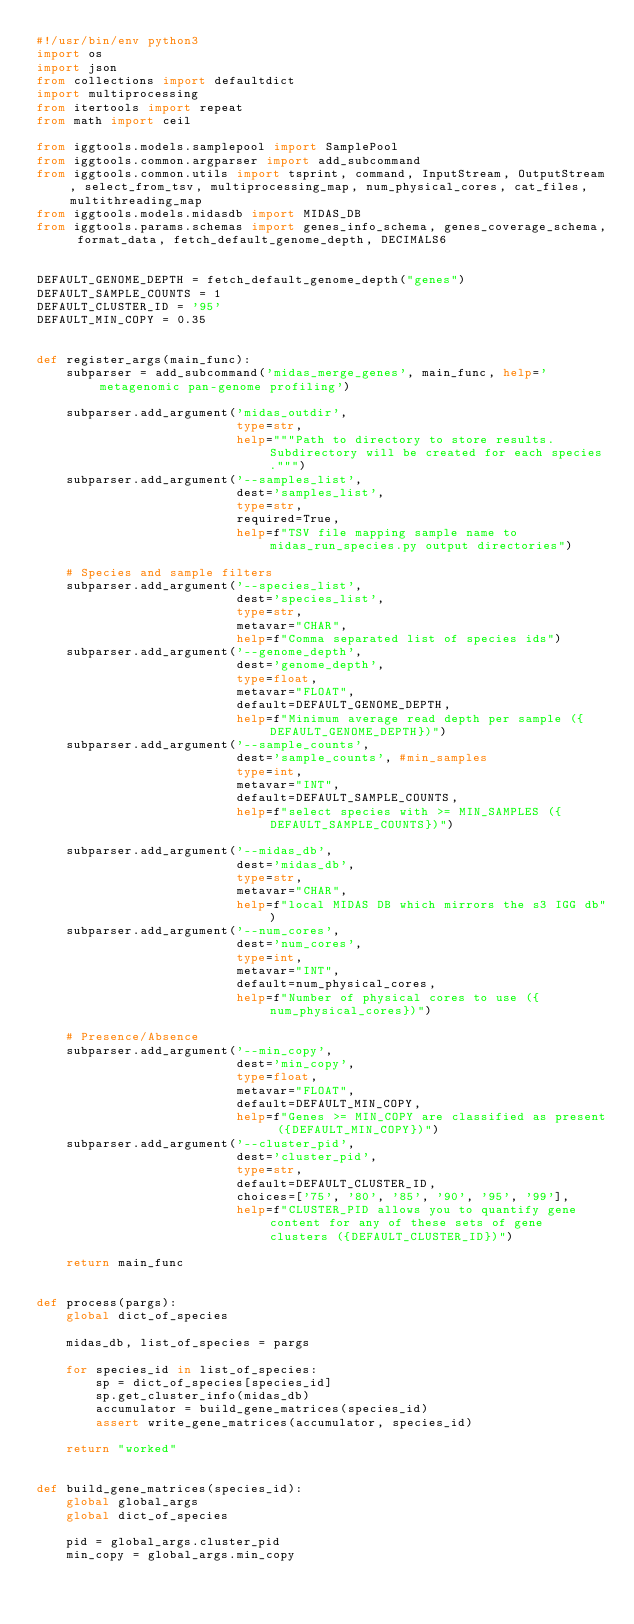Convert code to text. <code><loc_0><loc_0><loc_500><loc_500><_Python_>#!/usr/bin/env python3
import os
import json
from collections import defaultdict
import multiprocessing
from itertools import repeat
from math import ceil

from iggtools.models.samplepool import SamplePool
from iggtools.common.argparser import add_subcommand
from iggtools.common.utils import tsprint, command, InputStream, OutputStream, select_from_tsv, multiprocessing_map, num_physical_cores, cat_files, multithreading_map
from iggtools.models.midasdb import MIDAS_DB
from iggtools.params.schemas import genes_info_schema, genes_coverage_schema, format_data, fetch_default_genome_depth, DECIMALS6


DEFAULT_GENOME_DEPTH = fetch_default_genome_depth("genes")
DEFAULT_SAMPLE_COUNTS = 1
DEFAULT_CLUSTER_ID = '95'
DEFAULT_MIN_COPY = 0.35


def register_args(main_func):
    subparser = add_subcommand('midas_merge_genes', main_func, help='metagenomic pan-genome profiling')

    subparser.add_argument('midas_outdir',
                           type=str,
                           help="""Path to directory to store results.  Subdirectory will be created for each species.""")
    subparser.add_argument('--samples_list',
                           dest='samples_list',
                           type=str,
                           required=True,
                           help=f"TSV file mapping sample name to midas_run_species.py output directories")

    # Species and sample filters
    subparser.add_argument('--species_list',
                           dest='species_list',
                           type=str,
                           metavar="CHAR",
                           help=f"Comma separated list of species ids")
    subparser.add_argument('--genome_depth',
                           dest='genome_depth',
                           type=float,
                           metavar="FLOAT",
                           default=DEFAULT_GENOME_DEPTH,
                           help=f"Minimum average read depth per sample ({DEFAULT_GENOME_DEPTH})")
    subparser.add_argument('--sample_counts',
                           dest='sample_counts', #min_samples
                           type=int,
                           metavar="INT",
                           default=DEFAULT_SAMPLE_COUNTS,
                           help=f"select species with >= MIN_SAMPLES ({DEFAULT_SAMPLE_COUNTS})")

    subparser.add_argument('--midas_db',
                           dest='midas_db',
                           type=str,
                           metavar="CHAR",
                           help=f"local MIDAS DB which mirrors the s3 IGG db")
    subparser.add_argument('--num_cores',
                           dest='num_cores',
                           type=int,
                           metavar="INT",
                           default=num_physical_cores,
                           help=f"Number of physical cores to use ({num_physical_cores})")

    # Presence/Absence
    subparser.add_argument('--min_copy',
                           dest='min_copy',
                           type=float,
                           metavar="FLOAT",
                           default=DEFAULT_MIN_COPY,
                           help=f"Genes >= MIN_COPY are classified as present ({DEFAULT_MIN_COPY})")
    subparser.add_argument('--cluster_pid',
                           dest='cluster_pid',
                           type=str,
                           default=DEFAULT_CLUSTER_ID,
                           choices=['75', '80', '85', '90', '95', '99'],
                           help=f"CLUSTER_PID allows you to quantify gene content for any of these sets of gene clusters ({DEFAULT_CLUSTER_ID})")

    return main_func


def process(pargs):
    global dict_of_species

    midas_db, list_of_species = pargs

    for species_id in list_of_species:
        sp = dict_of_species[species_id]
        sp.get_cluster_info(midas_db)
        accumulator = build_gene_matrices(species_id)
        assert write_gene_matrices(accumulator, species_id)

    return "worked"


def build_gene_matrices(species_id):
    global global_args
    global dict_of_species

    pid = global_args.cluster_pid
    min_copy = global_args.min_copy
</code> 